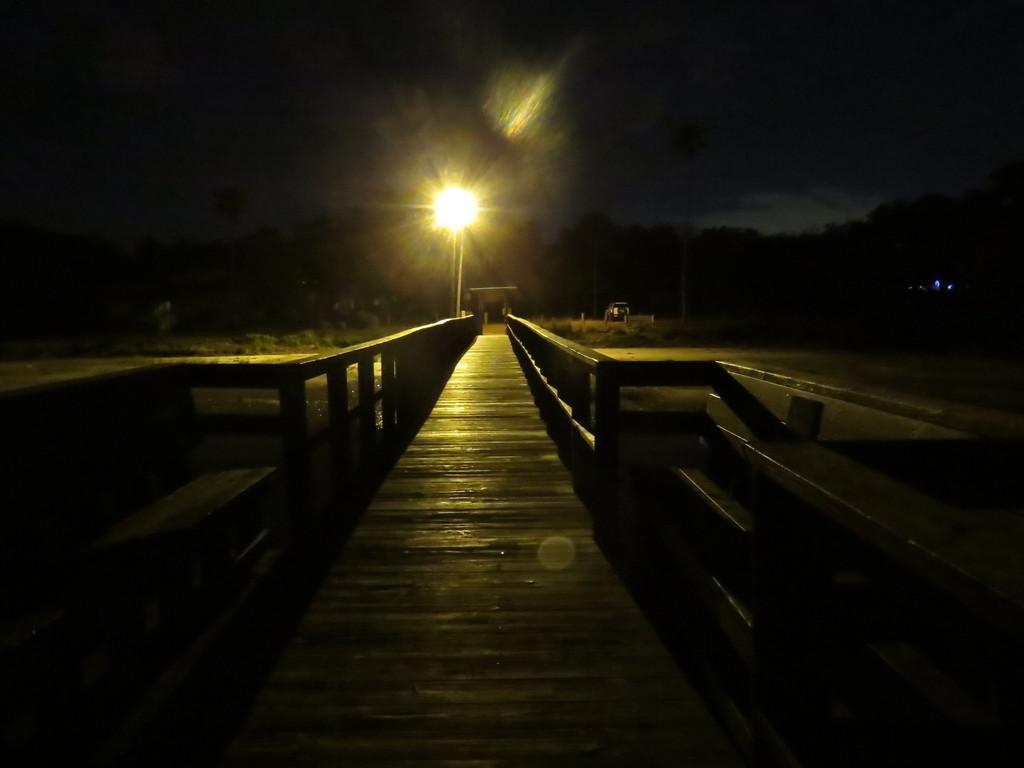Describe this image in one or two sentences. In the middle of this image, there is a bridge having a fence on both sides. In the background, there is light, there is a vehicle on the road, there are trees and there are clouds in the sky. 